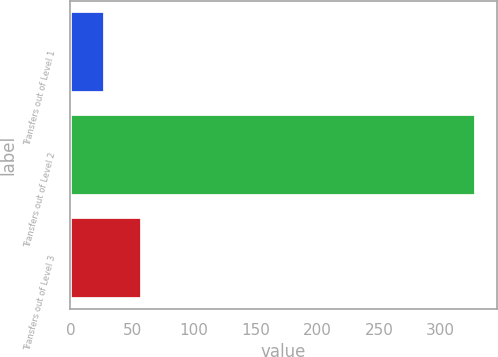Convert chart to OTSL. <chart><loc_0><loc_0><loc_500><loc_500><bar_chart><fcel>Transfers out of Level 1<fcel>Transfers out of Level 2<fcel>Transfers out of Level 3<nl><fcel>28<fcel>329<fcel>58.1<nl></chart> 